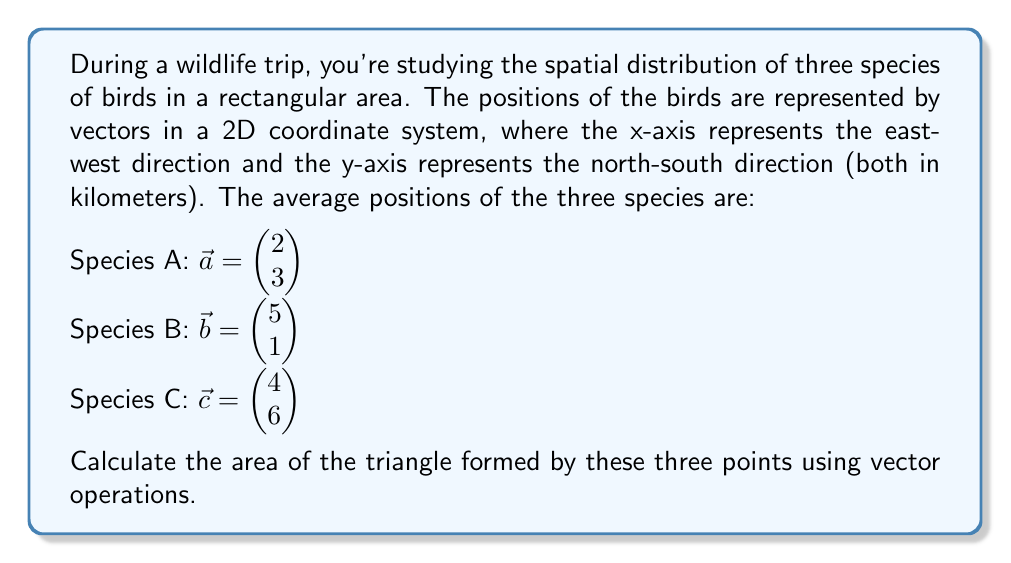Help me with this question. To solve this problem, we'll use the cross product of vectors. The steps are as follows:

1) First, we need to find two vectors that form the sides of the triangle. We can do this by subtracting the position vectors:

   $\vec{AB} = \vec{b} - \vec{a} = \begin{pmatrix} 5 \\ 1 \end{pmatrix} - \begin{pmatrix} 2 \\ 3 \end{pmatrix} = \begin{pmatrix} 3 \\ -2 \end{pmatrix}$
   
   $\vec{AC} = \vec{c} - \vec{a} = \begin{pmatrix} 4 \\ 6 \end{pmatrix} - \begin{pmatrix} 2 \\ 3 \end{pmatrix} = \begin{pmatrix} 2 \\ 3 \end{pmatrix}$

2) The area of a parallelogram formed by two vectors is equal to the magnitude of their cross product. The area of the triangle is half of this.

3) In 2D, the cross product of two vectors $\vec{u} = (u_x, u_y)$ and $\vec{v} = (v_x, v_y)$ is defined as:

   $\vec{u} \times \vec{v} = u_x v_y - u_y v_x$

4) Applying this to our vectors:

   $\vec{AB} \times \vec{AC} = (3)(3) - (-2)(2) = 9 + 4 = 13$

5) The magnitude of this cross product gives us the area of the parallelogram. To get the area of the triangle, we divide by 2:

   Area of triangle = $\frac{1}{2}|\vec{AB} \times \vec{AC}| = \frac{13}{2} = 6.5$

Therefore, the area of the triangle formed by the average positions of the three bird species is 6.5 square kilometers.
Answer: 6.5 km² 